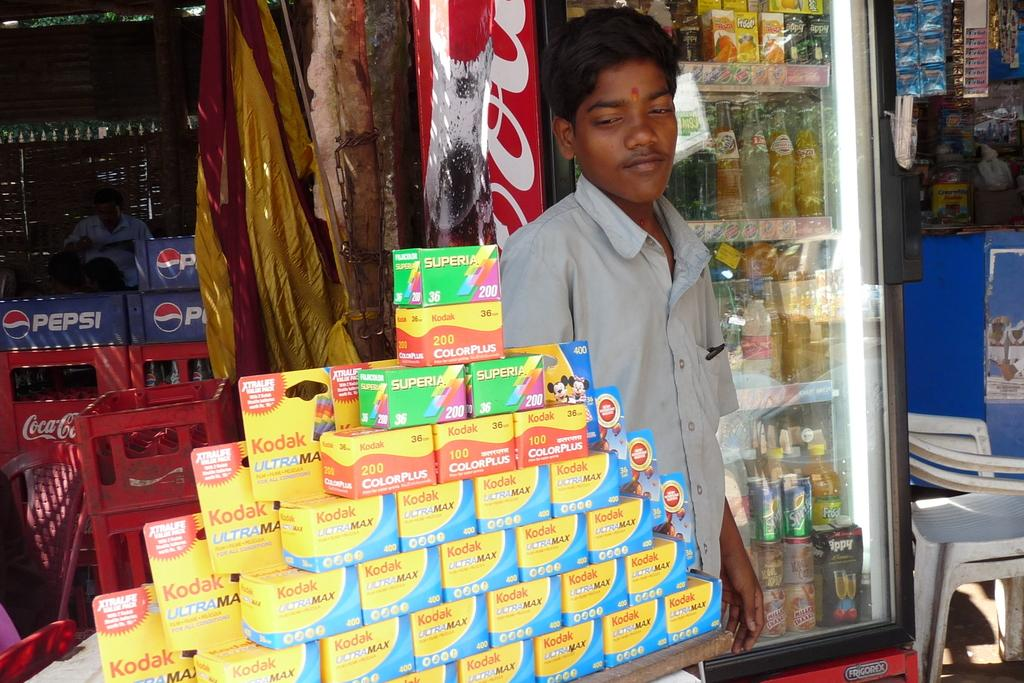<image>
Give a short and clear explanation of the subsequent image. A man stands behind a stack of Kodak products. 